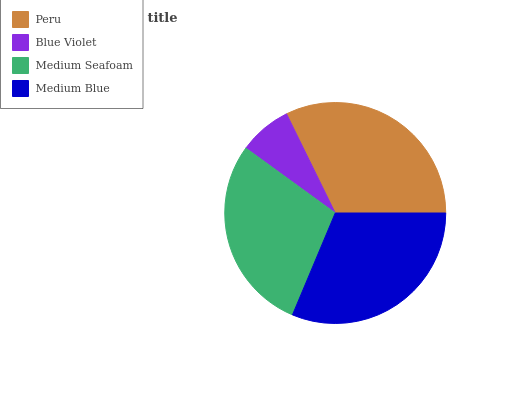Is Blue Violet the minimum?
Answer yes or no. Yes. Is Peru the maximum?
Answer yes or no. Yes. Is Medium Seafoam the minimum?
Answer yes or no. No. Is Medium Seafoam the maximum?
Answer yes or no. No. Is Medium Seafoam greater than Blue Violet?
Answer yes or no. Yes. Is Blue Violet less than Medium Seafoam?
Answer yes or no. Yes. Is Blue Violet greater than Medium Seafoam?
Answer yes or no. No. Is Medium Seafoam less than Blue Violet?
Answer yes or no. No. Is Medium Blue the high median?
Answer yes or no. Yes. Is Medium Seafoam the low median?
Answer yes or no. Yes. Is Medium Seafoam the high median?
Answer yes or no. No. Is Blue Violet the low median?
Answer yes or no. No. 